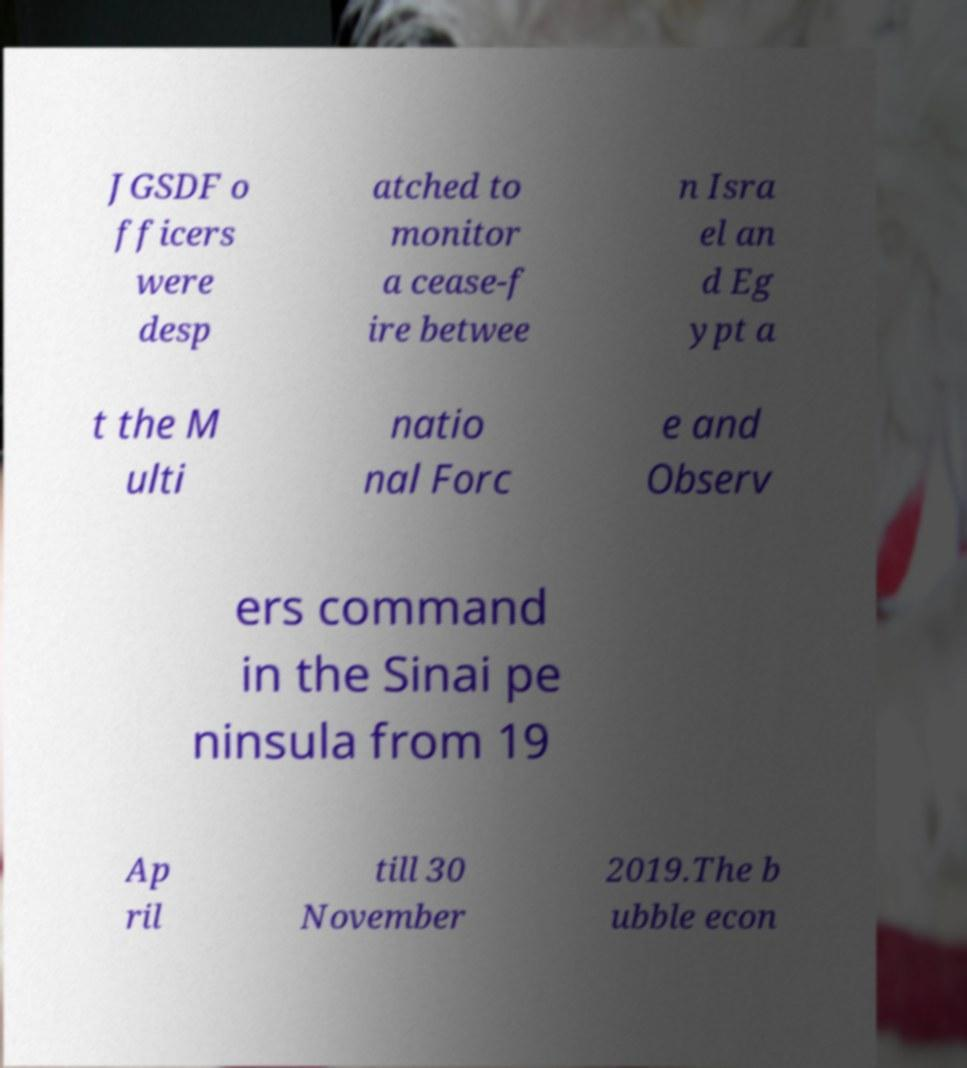Please identify and transcribe the text found in this image. JGSDF o fficers were desp atched to monitor a cease-f ire betwee n Isra el an d Eg ypt a t the M ulti natio nal Forc e and Observ ers command in the Sinai pe ninsula from 19 Ap ril till 30 November 2019.The b ubble econ 